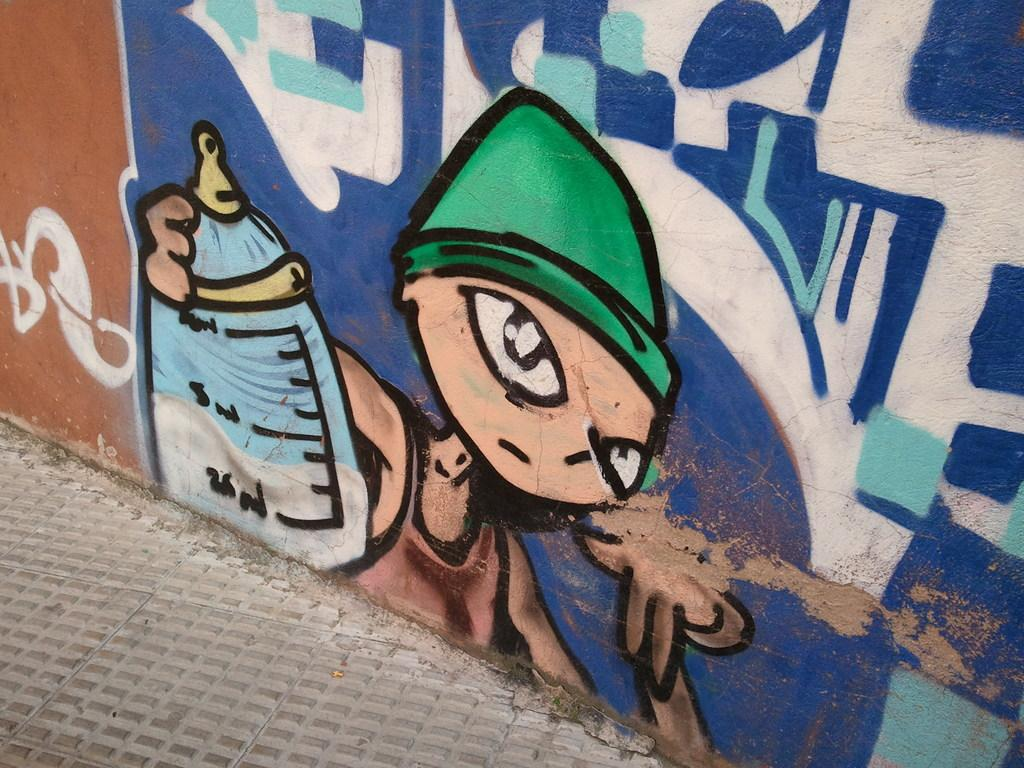What is present on the wall in the image? There is a painting of a boy holding a bottle on the wall. What else can be seen in the image besides the wall and the painting? There is a road at the bottom of the image. What type of cherry is being used as a button on the boy's shirt in the painting? There is no cherry or button present on the boy's shirt in the painting; he is holding a bottle. How many weeks are depicted in the image? There are no weeks depicted in the image; it features a painting of a boy holding a bottle on a wall. 